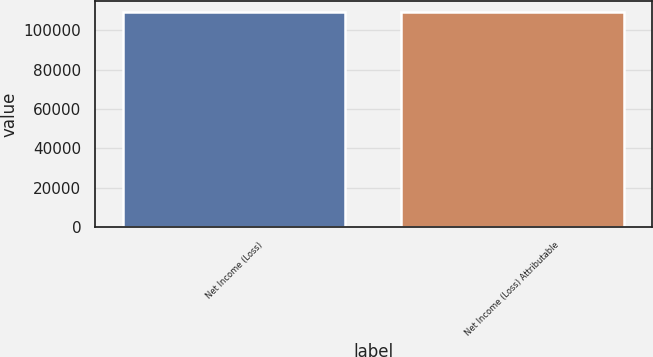<chart> <loc_0><loc_0><loc_500><loc_500><bar_chart><fcel>Net Income (Loss)<fcel>Net Income (Loss) Attributable<nl><fcel>109188<fcel>109094<nl></chart> 